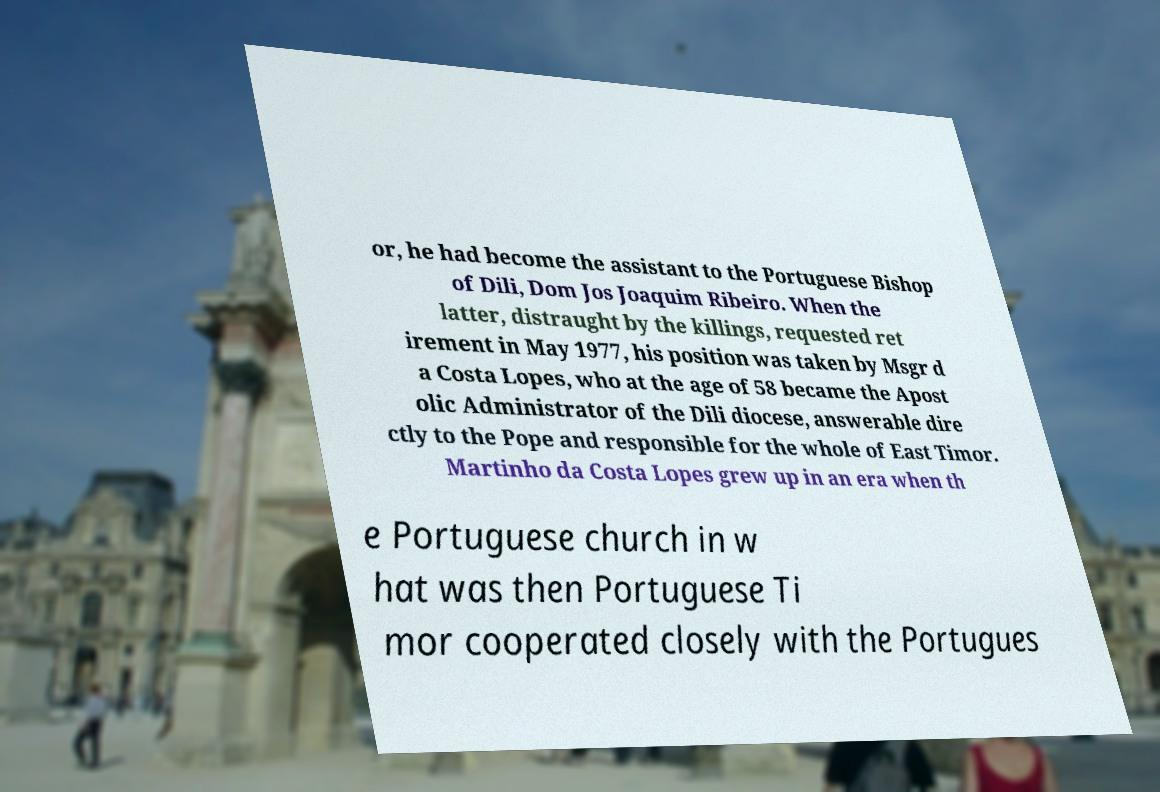Could you assist in decoding the text presented in this image and type it out clearly? or, he had become the assistant to the Portuguese Bishop of Dili, Dom Jos Joaquim Ribeiro. When the latter, distraught by the killings, requested ret irement in May 1977, his position was taken by Msgr d a Costa Lopes, who at the age of 58 became the Apost olic Administrator of the Dili diocese, answerable dire ctly to the Pope and responsible for the whole of East Timor. Martinho da Costa Lopes grew up in an era when th e Portuguese church in w hat was then Portuguese Ti mor cooperated closely with the Portugues 